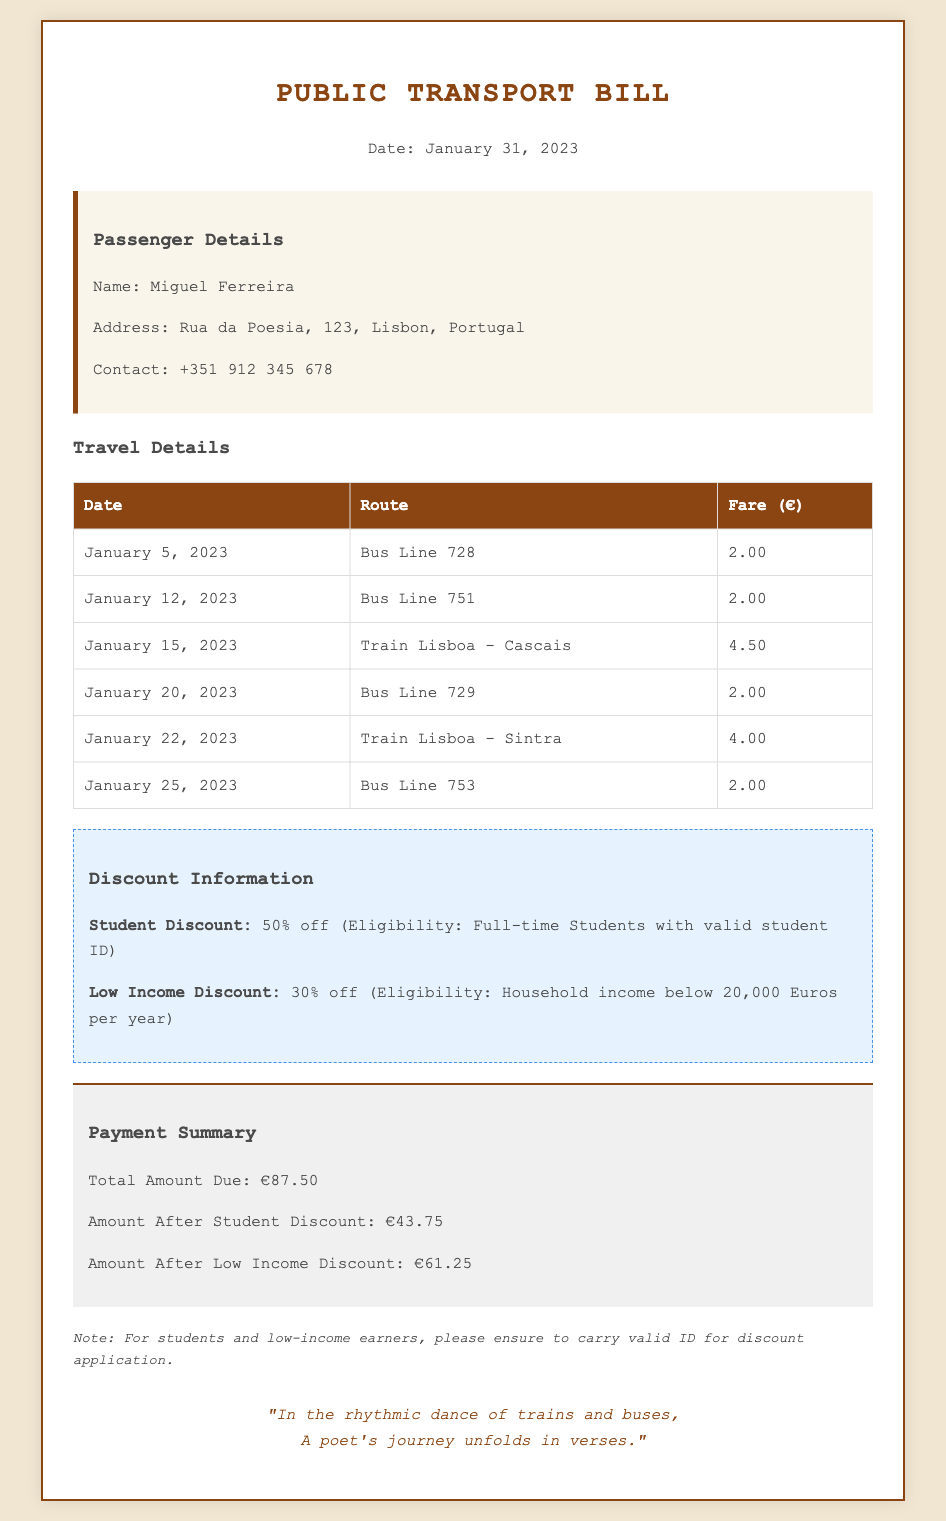What is the name of the passenger? The name of the passenger is mentioned in the passenger details section of the document.
Answer: Miguel Ferreira What is the total amount due? The total amount due is stated in the payment summary section of the document.
Answer: €87.50 On what date did the passenger travel on Train Lisboa - Cascais? The specific date for this travel is listed in the travel details table.
Answer: January 15, 2023 What percentage is the student discount? The student discount percentage is provided in the discount information section of the document.
Answer: 50% How many bus journeys did the passenger take in January? The travel details table shows the number of bus entries made by the passenger.
Answer: 4 What is the eligibility criteria for the low-income discount? The criteria for the low-income discount is detailed in the discount information section.
Answer: Household income below 20,000 Euros per year What is the fare for Bus Line 729? The fare for Bus Line 729 can be found in the travel details table.
Answer: €2.00 What is the final amount due after the low-income discount? The amount after applying the low-income discount is indicated in the payment summary.
Answer: €61.25 What color is the header section? The color can be inferred from the styling elements in the document.
Answer: Brown 